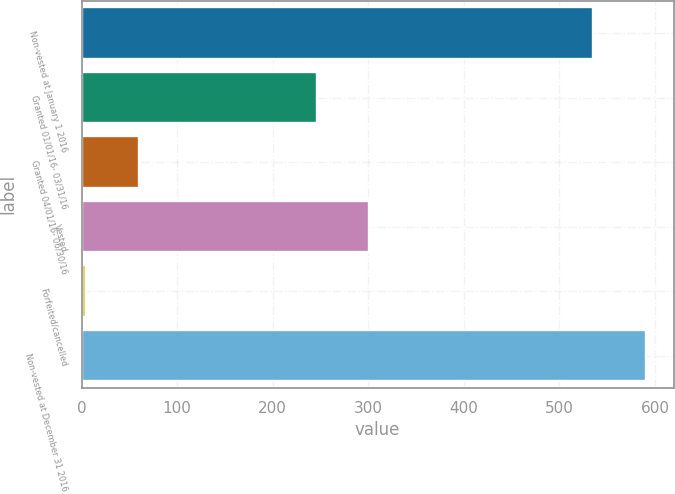Convert chart to OTSL. <chart><loc_0><loc_0><loc_500><loc_500><bar_chart><fcel>Non-vested at January 1 2016<fcel>Granted 01/01/16- 03/31/16<fcel>Granted 04/01/16- 06/30/16<fcel>Vested<fcel>Forfeited/cancelled<fcel>Non-vested at December 31 2016<nl><fcel>535<fcel>246<fcel>60.1<fcel>301.1<fcel>5<fcel>590.1<nl></chart> 